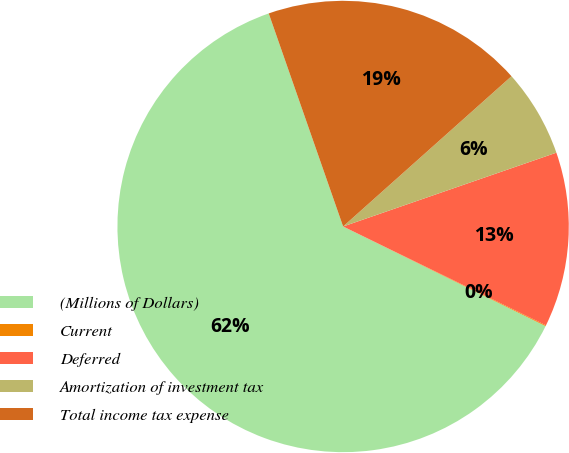<chart> <loc_0><loc_0><loc_500><loc_500><pie_chart><fcel>(Millions of Dollars)<fcel>Current<fcel>Deferred<fcel>Amortization of investment tax<fcel>Total income tax expense<nl><fcel>62.37%<fcel>0.06%<fcel>12.52%<fcel>6.29%<fcel>18.75%<nl></chart> 